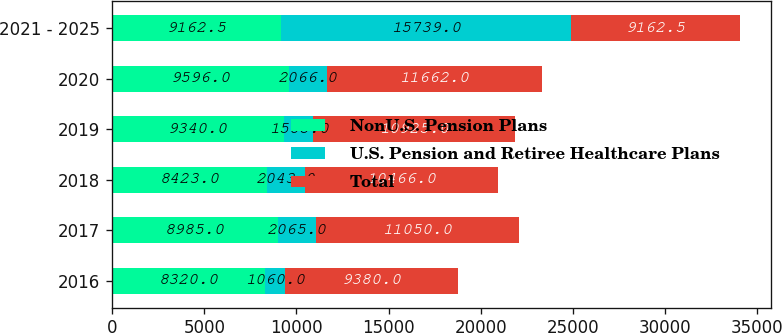<chart> <loc_0><loc_0><loc_500><loc_500><stacked_bar_chart><ecel><fcel>2016<fcel>2017<fcel>2018<fcel>2019<fcel>2020<fcel>2021 - 2025<nl><fcel>NonU.S. Pension Plans<fcel>8320<fcel>8985<fcel>8423<fcel>9340<fcel>9596<fcel>9162.5<nl><fcel>U.S. Pension and Retiree Healthcare Plans<fcel>1060<fcel>2065<fcel>2043<fcel>1585<fcel>2066<fcel>15739<nl><fcel>Total<fcel>9380<fcel>11050<fcel>10466<fcel>10925<fcel>11662<fcel>9162.5<nl></chart> 